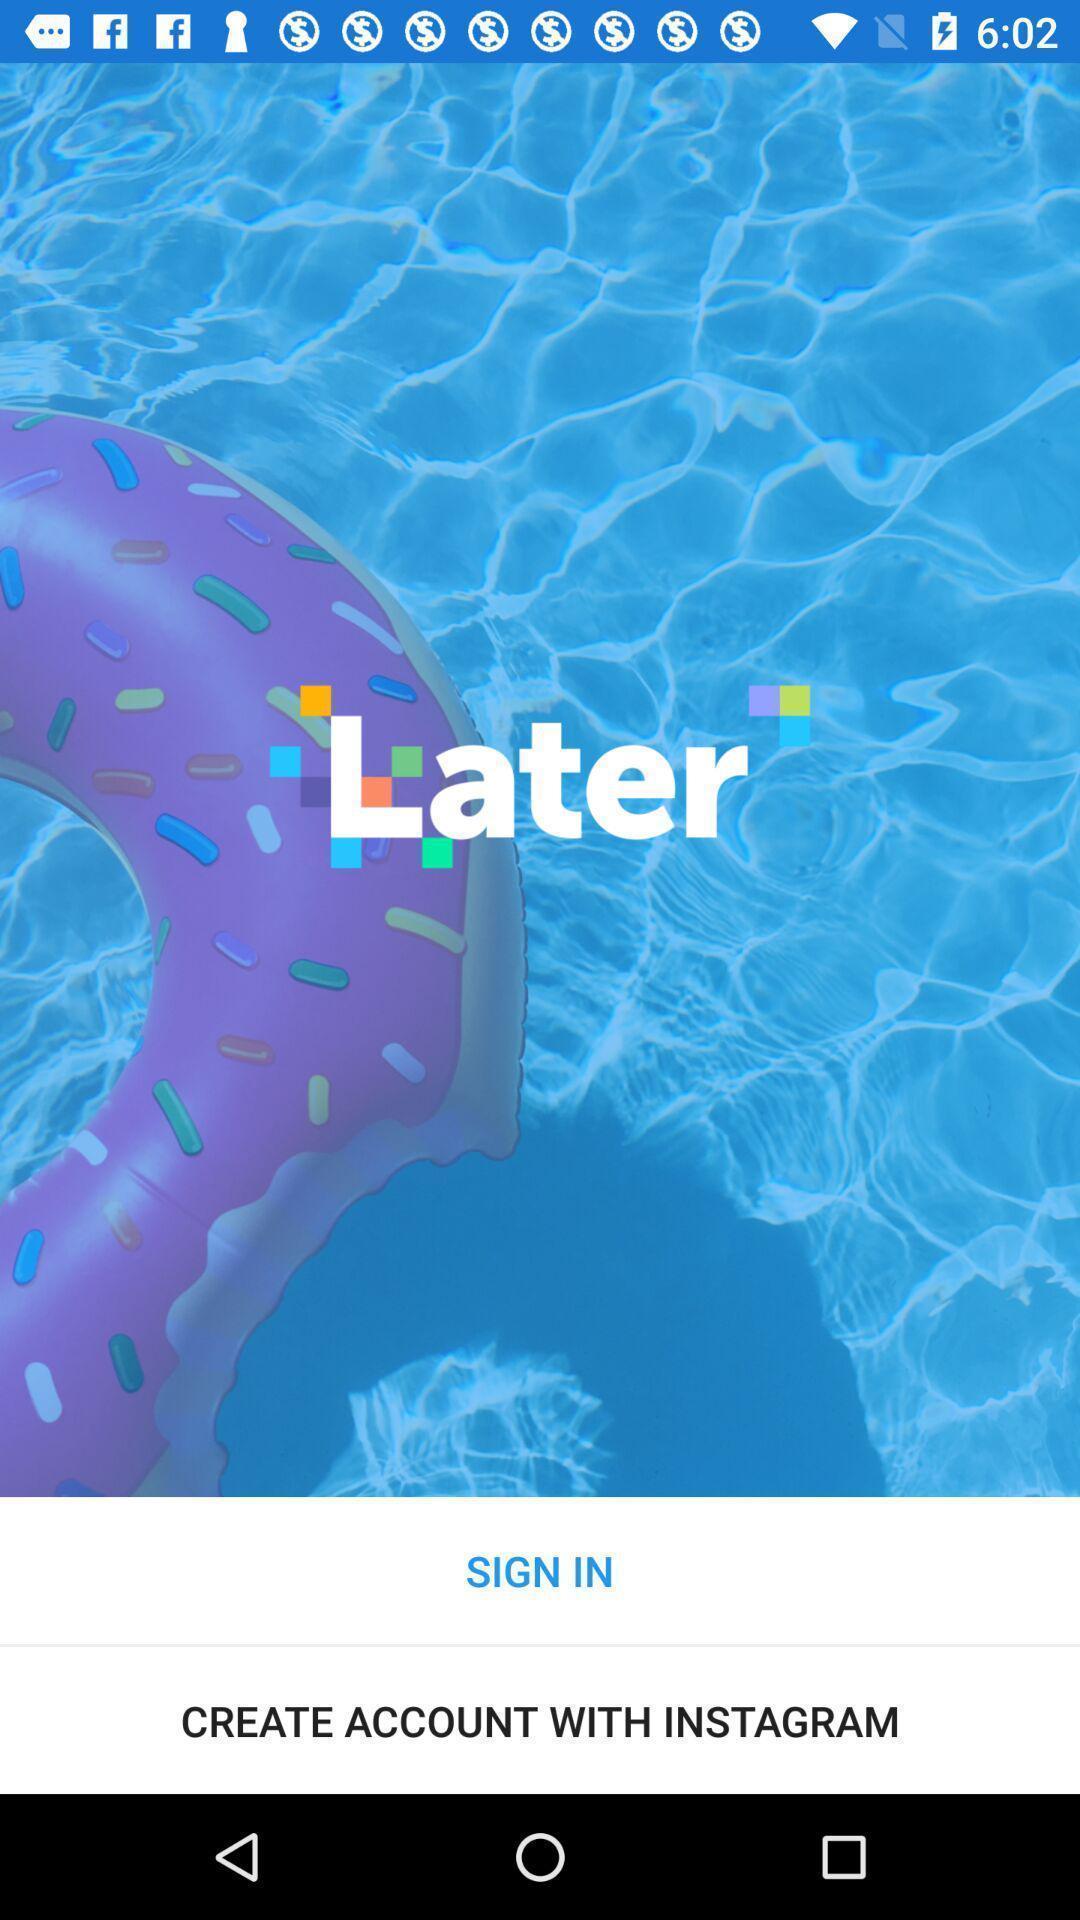Summarize the information in this screenshot. Welcome page of social application. 